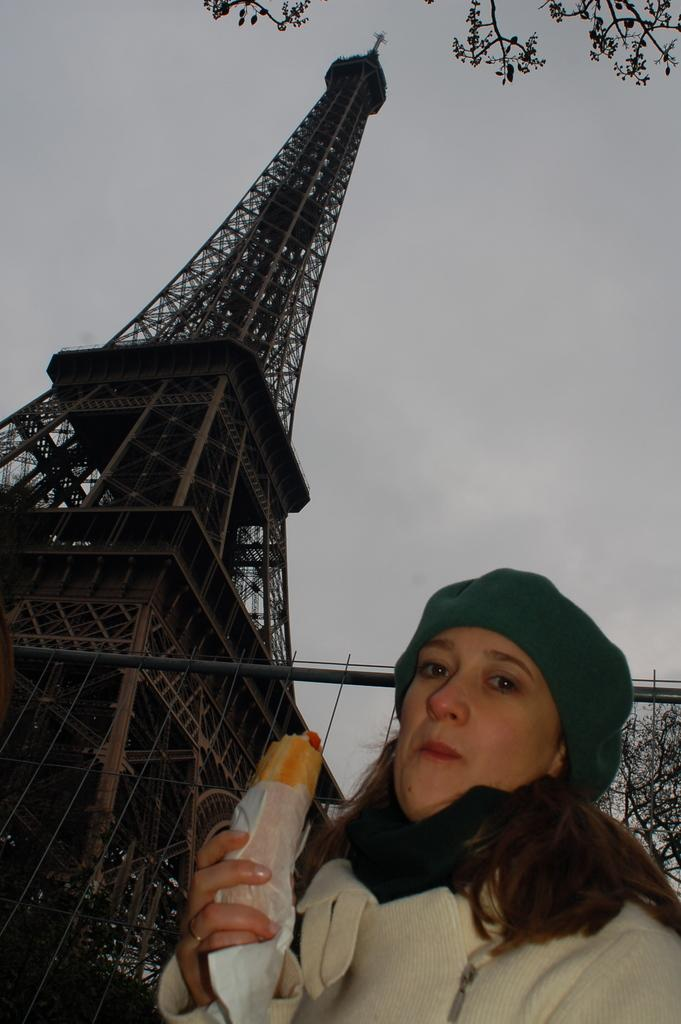Who is present in the image? There is a woman in the image. Where is the woman located in the image? The woman is in the right corner of the image. What is the woman holding in her hand? The woman is holding an edible in her hand. What famous landmark can be seen in the image? There is an Eiffel Tower in the image. Where is the Eiffel Tower located in the image? The Eiffel Tower is in the left corner of the image. What type of owl can be seen perched on the scarecrow in the image? There is no owl or scarecrow present in the image. 